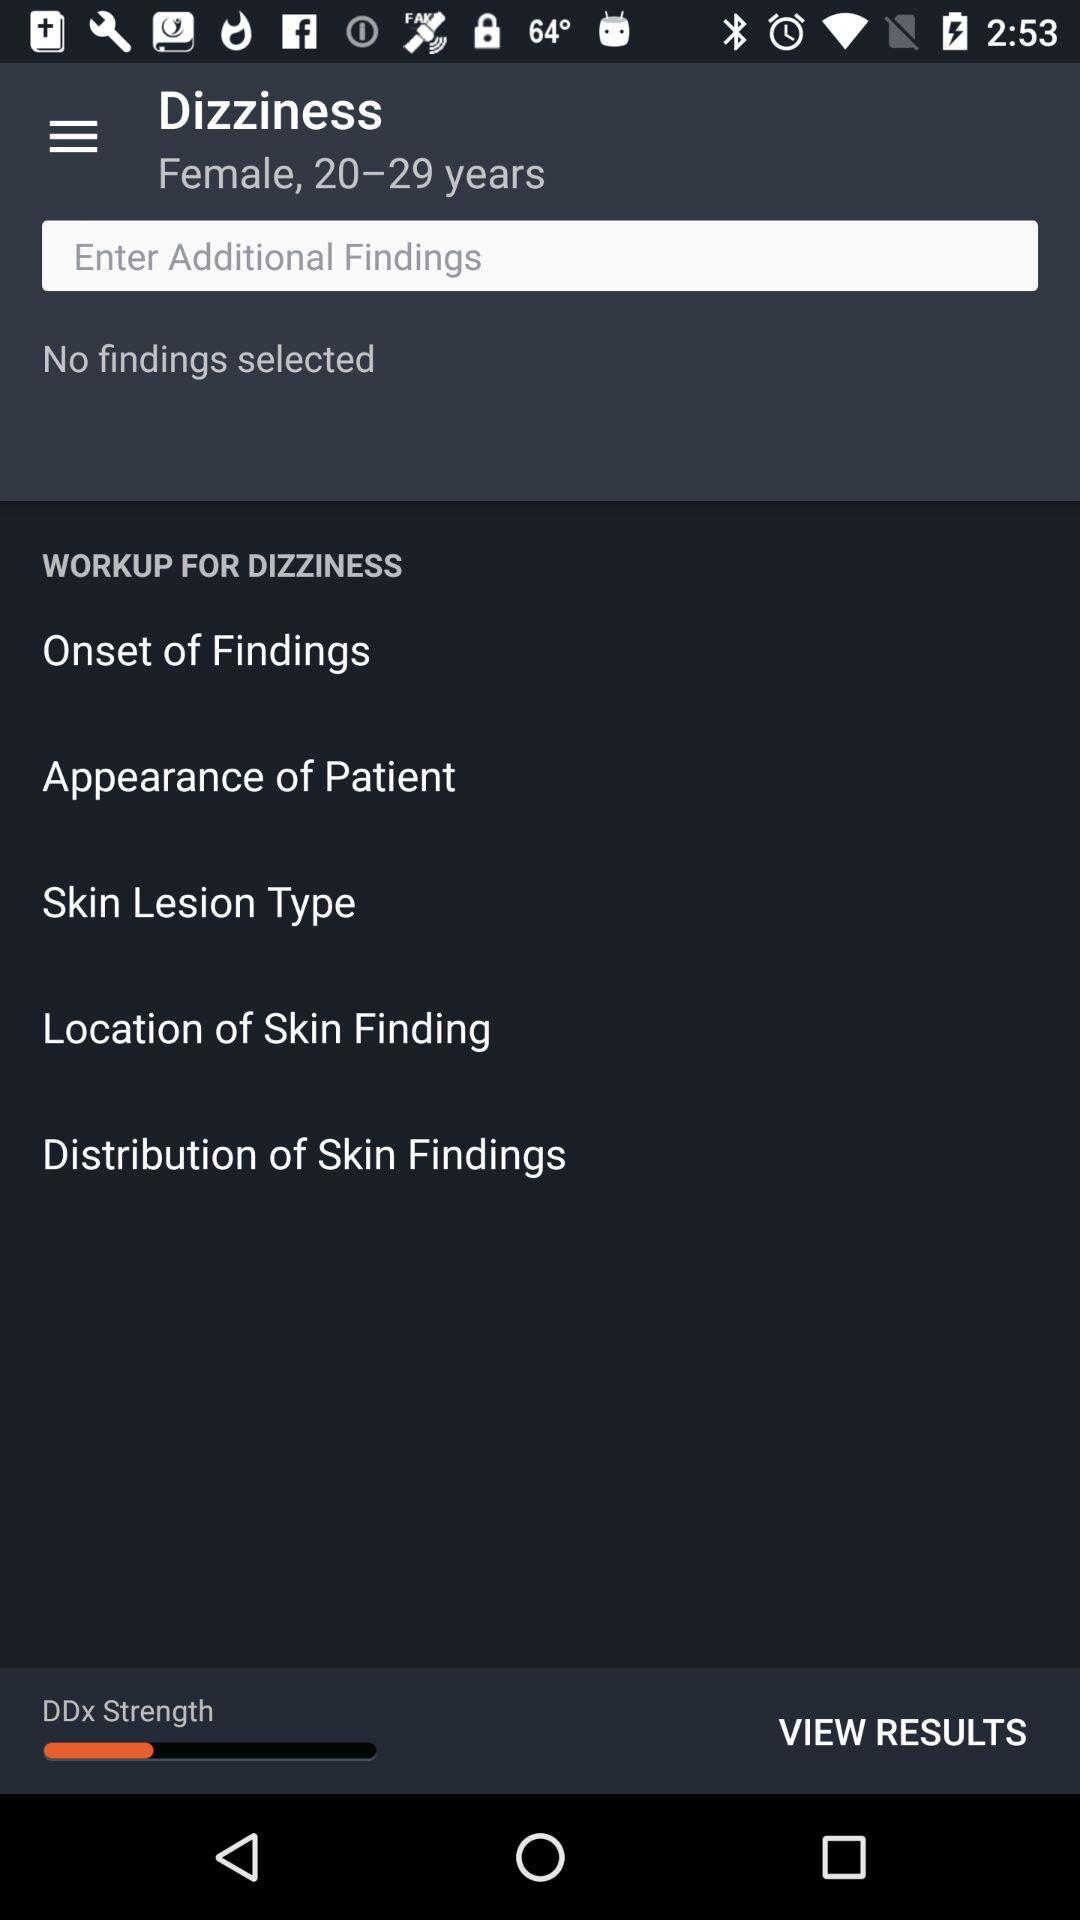What is the gender? The gender is female. 